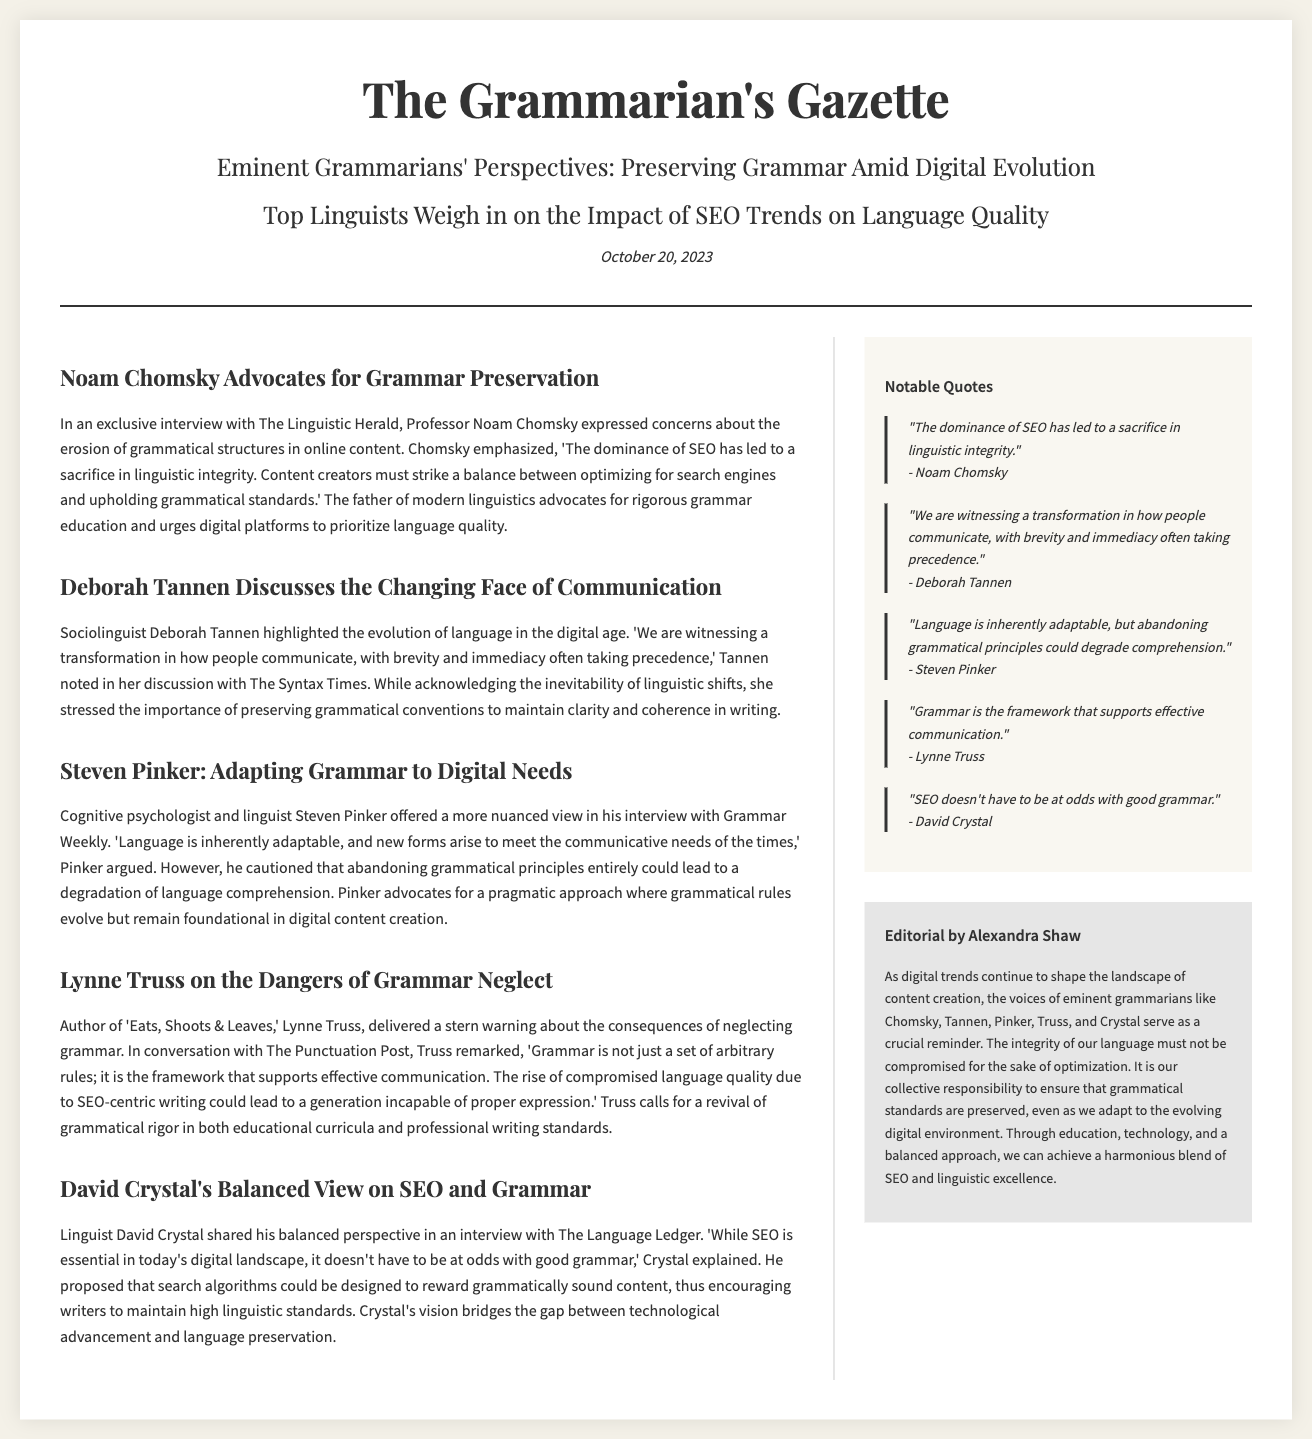What is the date of publication? The publication date is mentioned at the top of the document.
Answer: October 20, 2023 Who expressed concerns about the erosion of grammatical structures? The document quotes Professor Noam Chomsky discussing grammatical concerns.
Answer: Noam Chomsky Which linguist discussed the importance of preserving grammatical conventions? The document notes Deborah Tannen's emphasis on grammatical conventions.
Answer: Deborah Tannen What does Steven Pinker advocate regarding grammatical rules? The document highlights Pinker's views on the adaptability of grammar while preserving principles.
Answer: A pragmatic approach What is the title of Lynne Truss's book? The document references her well-known book in the article.
Answer: Eats, Shoots & Leaves Which linguist believes that SEO can coexist with good grammar? The document states David Crystal's view on the compatibility of SEO and grammar.
Answer: David Crystal What type of content does the sidebar include? The sidebar consists of notable quotes and an editorial from a contributor.
Answer: Notable quotes Which linguist delivered a stern warning about grammar neglect? The document identifies Lynne Truss as the linguist who warned about neglecting grammar.
Answer: Lynne Truss 